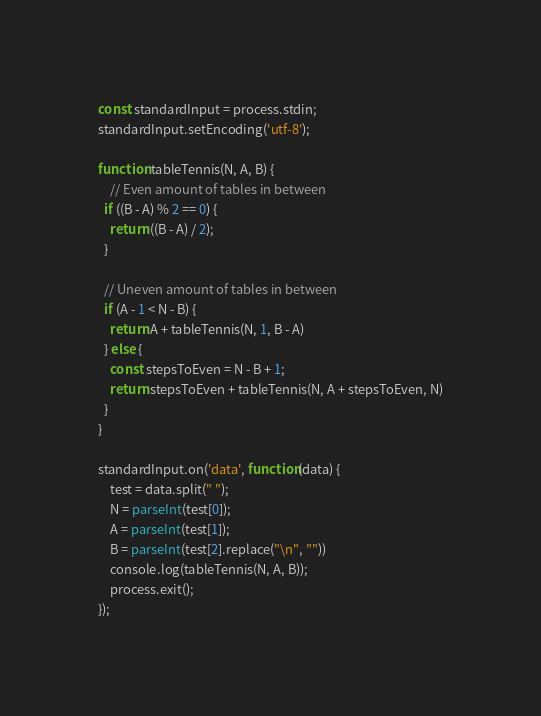Convert code to text. <code><loc_0><loc_0><loc_500><loc_500><_JavaScript_>const standardInput = process.stdin;
standardInput.setEncoding('utf-8');

function tableTennis(N, A, B) {
    // Even amount of tables in between
  if ((B - A) % 2 == 0) {
    return ((B - A) / 2);
  }
  
  // Uneven amount of tables in between
  if (A - 1 < N - B) {
    return A + tableTennis(N, 1, B - A)
  } else {
    const stepsToEven = N - B + 1;
    return stepsToEven + tableTennis(N, A + stepsToEven, N)
  }
}

standardInput.on('data', function(data) {
    test = data.split(" ");
    N = parseInt(test[0]);
    A = parseInt(test[1]);
    B = parseInt(test[2].replace("\n", ""))
    console.log(tableTennis(N, A, B));
    process.exit();
});
</code> 